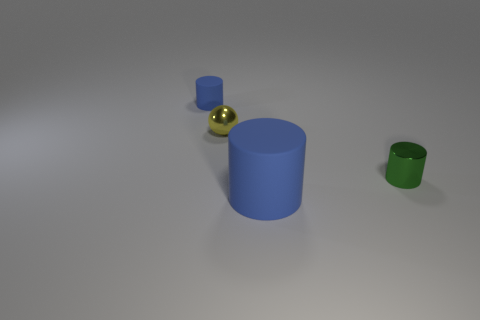Subtract all green metallic cylinders. How many cylinders are left? 2 Add 4 tiny green things. How many objects exist? 8 Subtract all green cylinders. How many cylinders are left? 2 Subtract 1 spheres. How many spheres are left? 0 Subtract all balls. How many objects are left? 3 Add 3 large blue cylinders. How many large blue cylinders are left? 4 Add 1 large gray rubber things. How many large gray rubber things exist? 1 Subtract 0 brown cylinders. How many objects are left? 4 Subtract all purple cylinders. Subtract all cyan blocks. How many cylinders are left? 3 Subtract all purple cylinders. How many blue balls are left? 0 